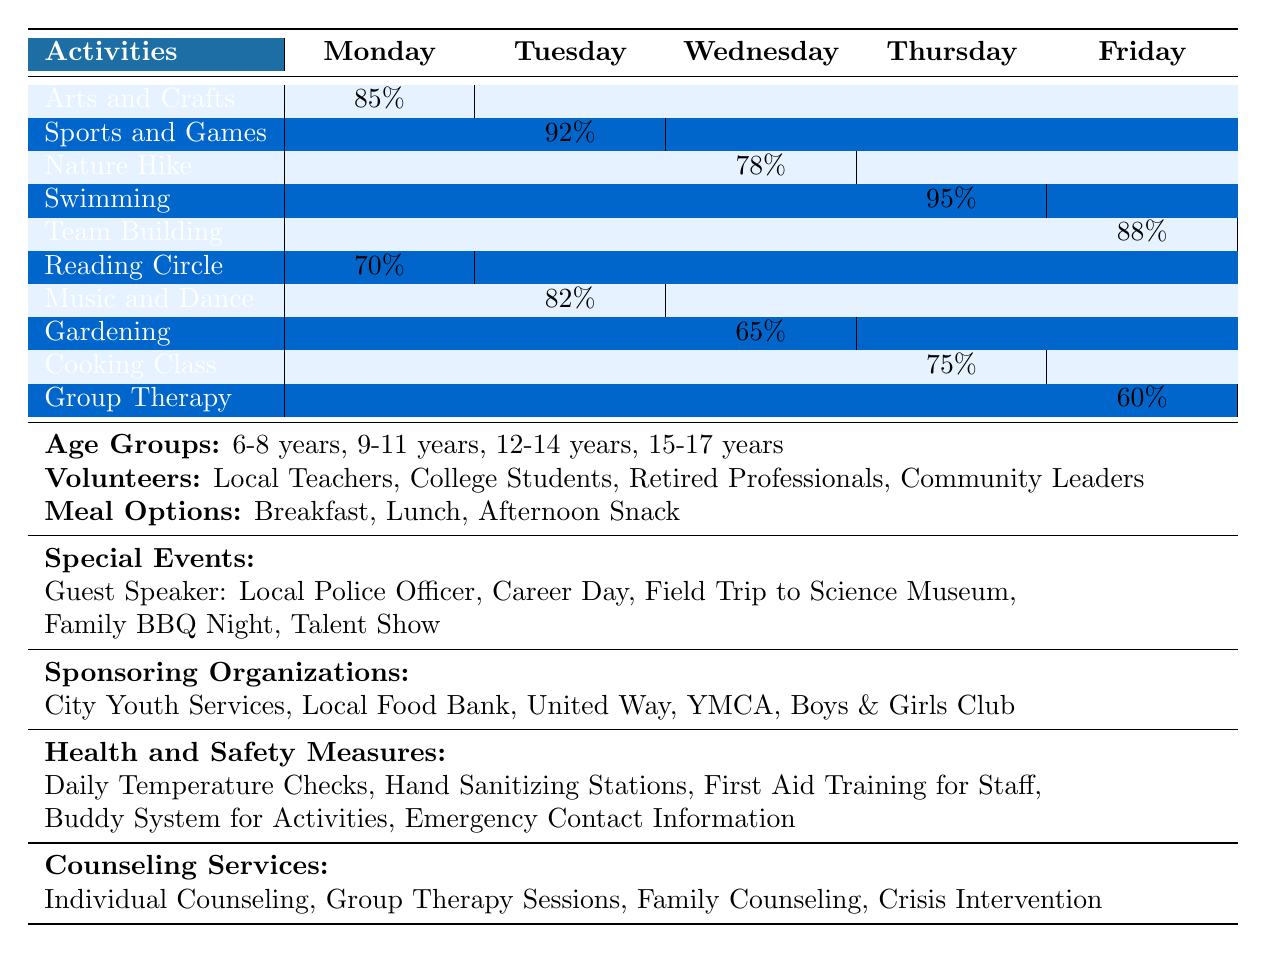What activity has the highest participation rate on Thursday? According to the table, the activity with the highest participation rate on Thursday is Swimming, which has a rate of 95%.
Answer: Swimming Which activity has the lowest participation rate overall? The activity with the lowest participation rate overall is Group Therapy, which has a participation rate of 60%.
Answer: Group Therapy What is the average participation rate for activities on Monday? There are two activities on Monday: Arts and Crafts (85%) and Reading Circle (70%). To find the average, sum them up (85 + 70 = 155) and divide by the number of activities (2): 155/2 = 77.5%.
Answer: 77.5% Did Nature Hike have a higher or lower participation rate than Music and Dance? Nature Hike had a participation rate of 78%, while Music and Dance had a rate of 82%. Since 78% is lower than 82%, Nature Hike had a lower participation rate.
Answer: Lower Which day had the highest participation rate for any activity? The day with the highest participation rate for any activity is Thursday, with Swimming at 95%.
Answer: Thursday What percentage above the average was Team Building's participation rate if the average participation rate is 77%? Team Building had a participation rate of 88%. To find how much higher it is than the average, subtract the average from Team Building's rate: 88 - 77 = 11%.
Answer: 11% Is there a consistent meal option provided every day? Yes, it seems that Breakfast, Lunch, and Afternoon Snack are offered as meal options throughout the week, indicating consistent meal support.
Answer: Yes How many activities had a participation rate below 80%? The activities with participation rates below 80% are Nature Hike (78%), Gardening (65%), and Group Therapy (60%). This totals to three activities.
Answer: Three What is the total participation rate of all activities across the week? To calculate the total participation rate, add the participation rates of all activities: 85 + 92 + 78 + 95 + 88 + 70 + 82 + 65 + 75 + 60 =  820%.
Answer: 820% Which day had the second lowest participation rate for an activity? Friday is the second lowest day for participation, with Group Therapy at 60%.
Answer: Friday 